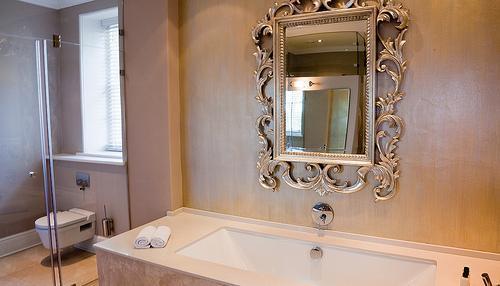How many towels are shown?
Give a very brief answer. 2. 